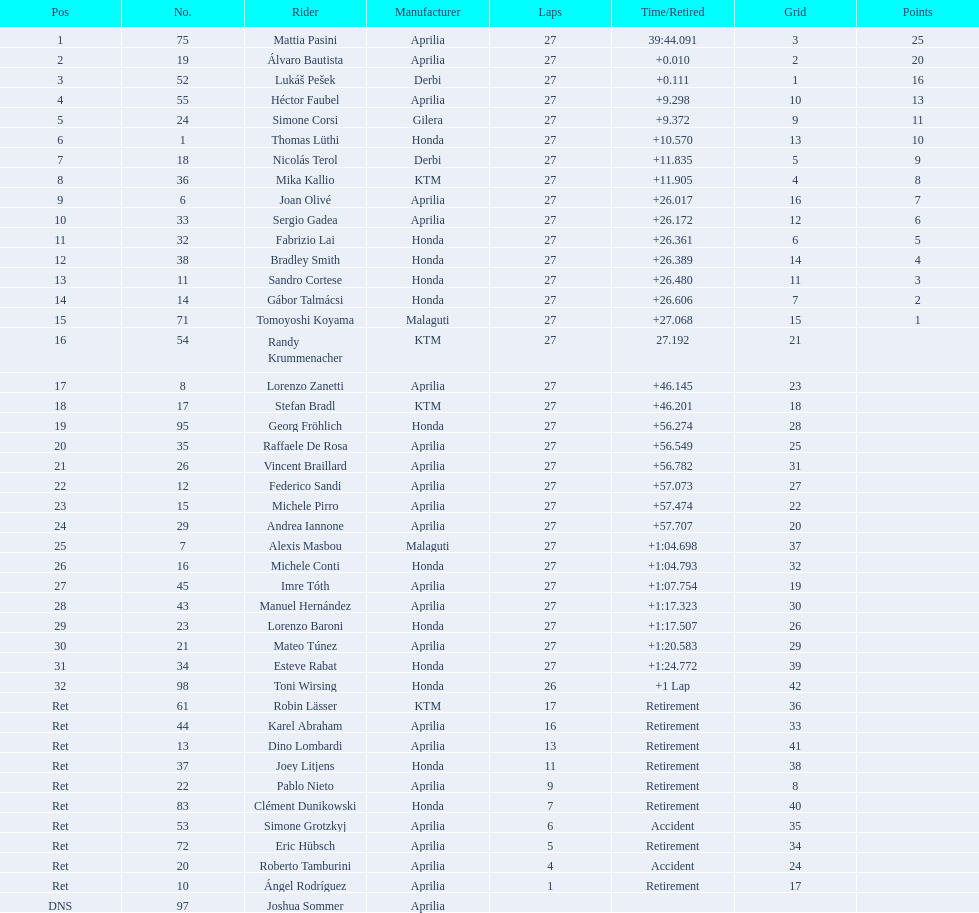Out of everyone with points, who has the smallest number? Tomoyoshi Koyama. 